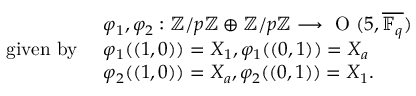<formula> <loc_0><loc_0><loc_500><loc_500>\begin{array} { r l } & { \varphi _ { 1 } , \varphi _ { 2 } \colon { \mathbb { Z } } / p { \mathbb { Z } } \oplus { \mathbb { Z } } / p { \mathbb { Z } } \longrightarrow O ( 5 , \overline { { \mathbb { F } _ { q } } } ) } \\ { g i v e n b y } & { \varphi _ { 1 } ( ( 1 , 0 ) ) = X _ { 1 } , \varphi _ { 1 } ( ( 0 , 1 ) ) = X _ { a } } \\ & { \varphi _ { 2 } ( ( 1 , 0 ) ) = X _ { a } , \varphi _ { 2 } ( ( 0 , 1 ) ) = X _ { 1 } . } \end{array}</formula> 